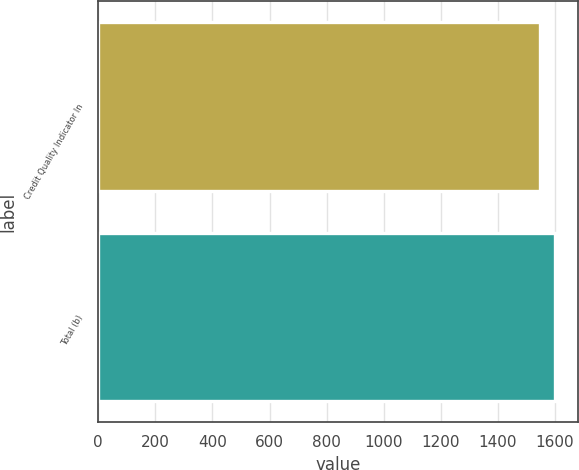<chart> <loc_0><loc_0><loc_500><loc_500><bar_chart><fcel>Credit Quality Indicator In<fcel>Total (b)<nl><fcel>1549<fcel>1599<nl></chart> 